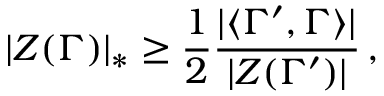Convert formula to latex. <formula><loc_0><loc_0><loc_500><loc_500>| Z ( \Gamma ) | _ { * } \geq \frac { 1 } { 2 } \frac { | \langle \Gamma ^ { \prime } , \Gamma \rangle | } { | Z ( \Gamma ^ { \prime } ) | } \, ,</formula> 